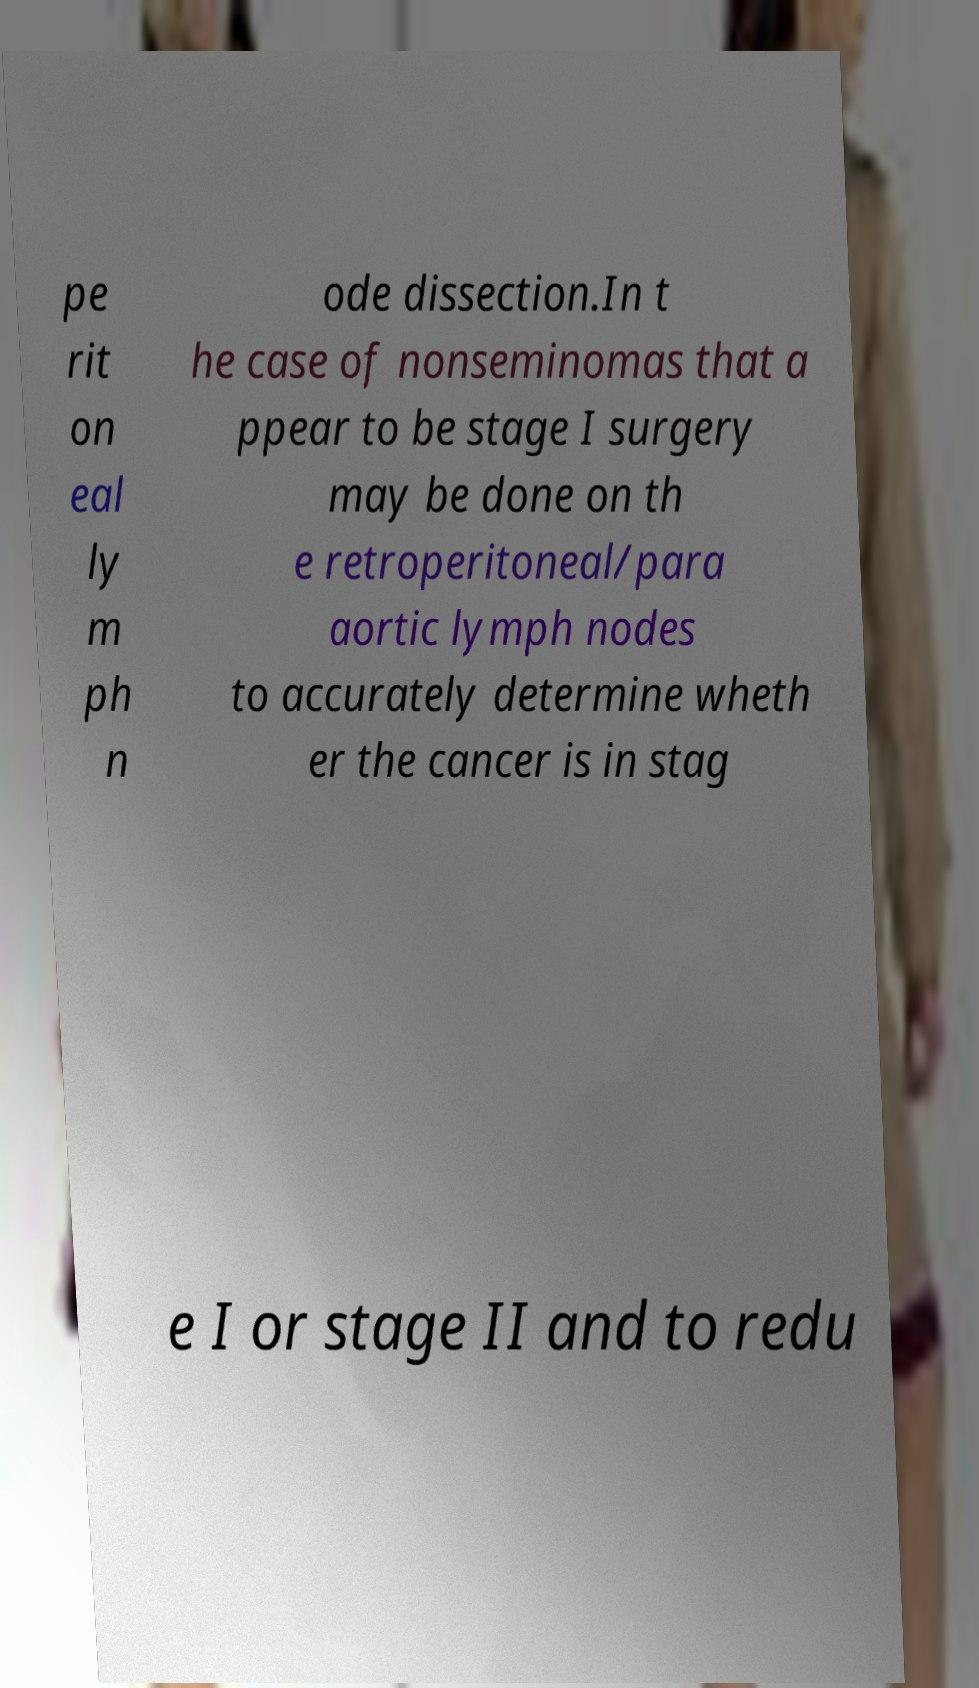Could you extract and type out the text from this image? pe rit on eal ly m ph n ode dissection.In t he case of nonseminomas that a ppear to be stage I surgery may be done on th e retroperitoneal/para aortic lymph nodes to accurately determine wheth er the cancer is in stag e I or stage II and to redu 